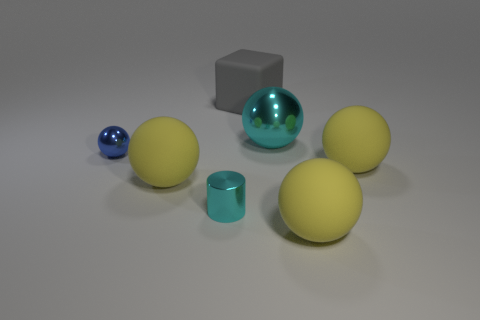Subtract all brown cubes. How many yellow balls are left? 3 Subtract all blue balls. How many balls are left? 4 Subtract all small spheres. How many spheres are left? 4 Subtract all purple balls. Subtract all blue cubes. How many balls are left? 5 Add 3 red objects. How many objects exist? 10 Subtract all cylinders. How many objects are left? 6 Subtract all large rubber cubes. Subtract all yellow balls. How many objects are left? 3 Add 6 tiny cyan metal objects. How many tiny cyan metal objects are left? 7 Add 6 yellow matte things. How many yellow matte things exist? 9 Subtract 0 red cylinders. How many objects are left? 7 